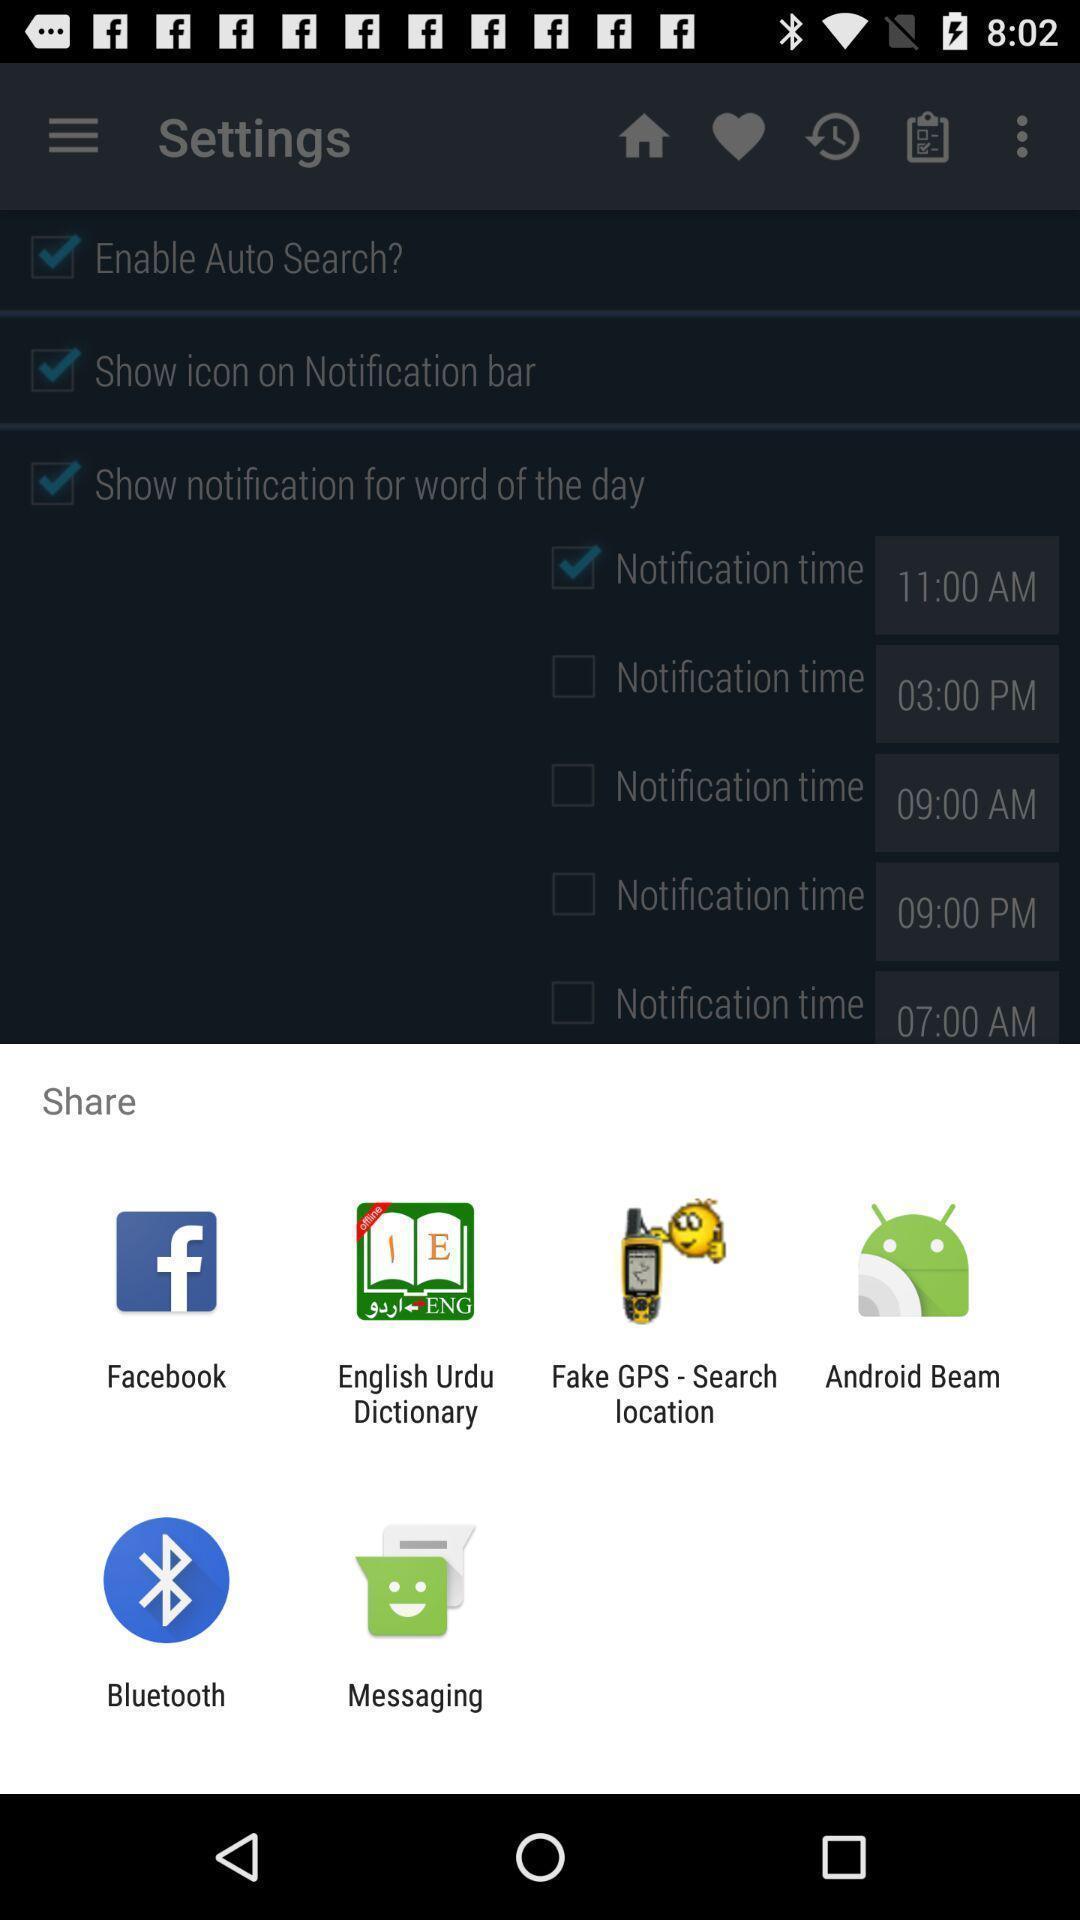Provide a detailed account of this screenshot. Popup displaying different apps to share. 